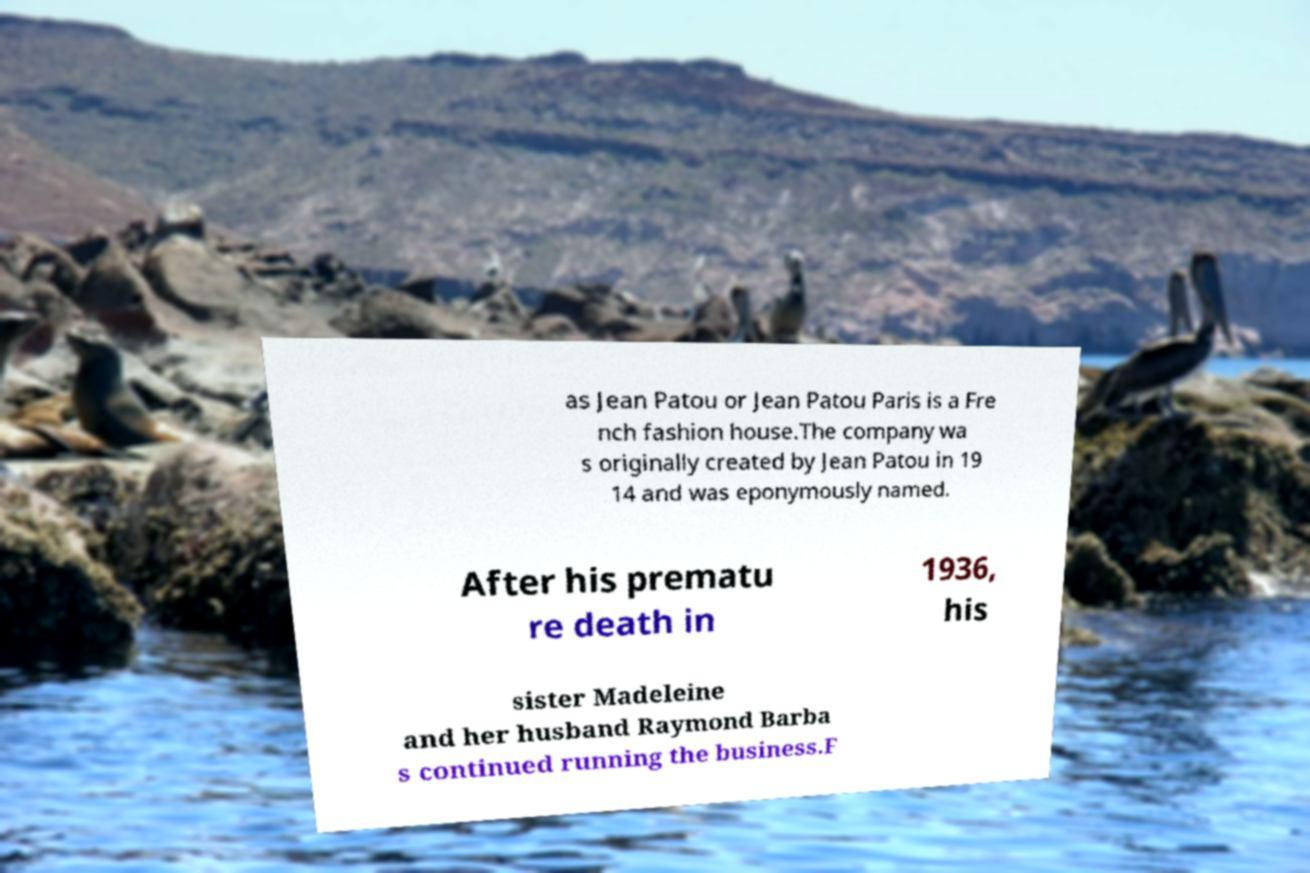I need the written content from this picture converted into text. Can you do that? as Jean Patou or Jean Patou Paris is a Fre nch fashion house.The company wa s originally created by Jean Patou in 19 14 and was eponymously named. After his prematu re death in 1936, his sister Madeleine and her husband Raymond Barba s continued running the business.F 